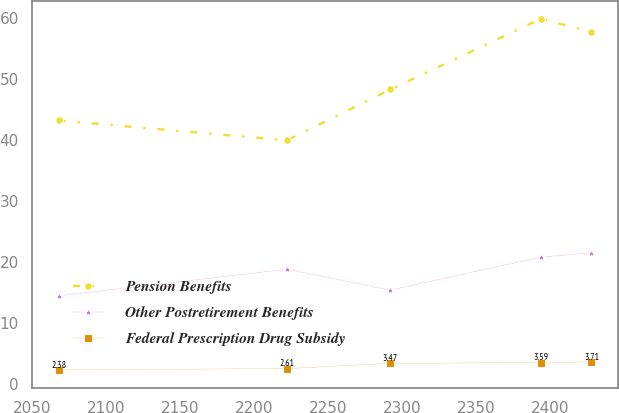<chart> <loc_0><loc_0><loc_500><loc_500><line_chart><ecel><fcel>Pension Benefits<fcel>Other Postretirement Benefits<fcel>Federal Prescription Drug Subsidy<nl><fcel>2067.6<fcel>43.28<fcel>14.53<fcel>2.38<nl><fcel>2222.16<fcel>40.03<fcel>18.9<fcel>2.61<nl><fcel>2292.15<fcel>48.36<fcel>15.47<fcel>3.47<nl><fcel>2394.01<fcel>59.94<fcel>20.89<fcel>3.59<nl><fcel>2428.32<fcel>57.8<fcel>21.58<fcel>3.71<nl></chart> 